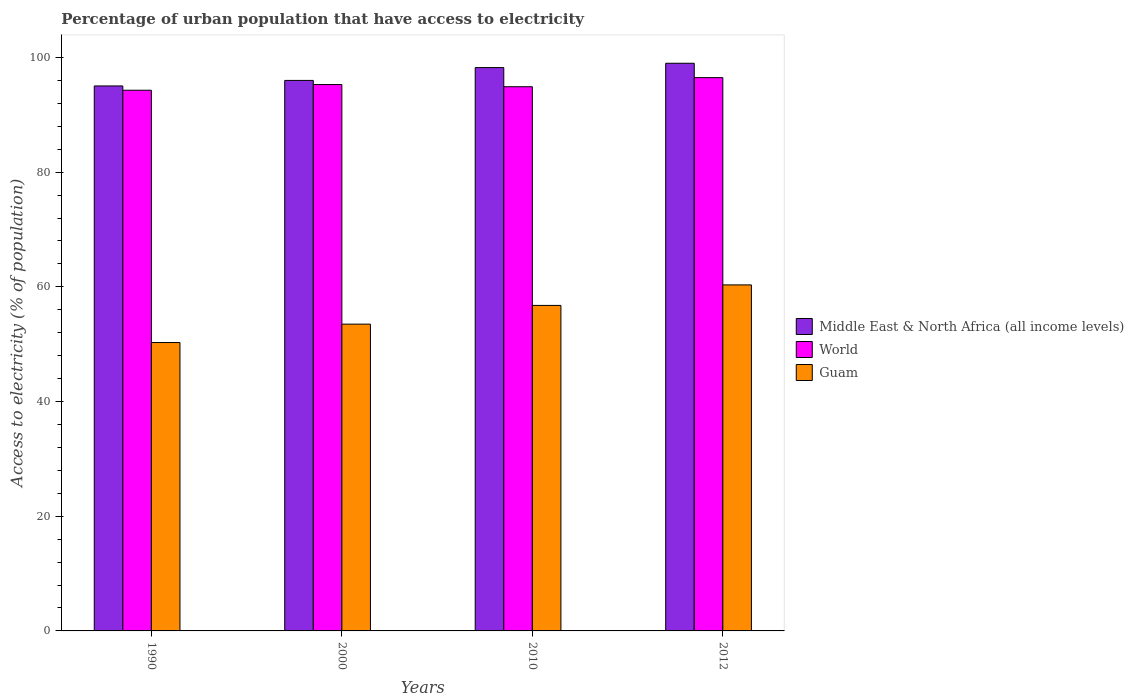How many groups of bars are there?
Your answer should be compact. 4. Are the number of bars per tick equal to the number of legend labels?
Keep it short and to the point. Yes. Are the number of bars on each tick of the X-axis equal?
Ensure brevity in your answer.  Yes. How many bars are there on the 4th tick from the left?
Your response must be concise. 3. What is the percentage of urban population that have access to electricity in World in 2010?
Offer a terse response. 94.89. Across all years, what is the maximum percentage of urban population that have access to electricity in Guam?
Offer a very short reply. 60.33. Across all years, what is the minimum percentage of urban population that have access to electricity in Middle East & North Africa (all income levels)?
Ensure brevity in your answer.  95.03. In which year was the percentage of urban population that have access to electricity in Guam minimum?
Keep it short and to the point. 1990. What is the total percentage of urban population that have access to electricity in Middle East & North Africa (all income levels) in the graph?
Give a very brief answer. 388.23. What is the difference between the percentage of urban population that have access to electricity in Guam in 1990 and that in 2000?
Offer a terse response. -3.21. What is the difference between the percentage of urban population that have access to electricity in Guam in 2010 and the percentage of urban population that have access to electricity in Middle East & North Africa (all income levels) in 1990?
Provide a succinct answer. -38.27. What is the average percentage of urban population that have access to electricity in World per year?
Your response must be concise. 95.23. In the year 2010, what is the difference between the percentage of urban population that have access to electricity in Guam and percentage of urban population that have access to electricity in World?
Keep it short and to the point. -38.13. In how many years, is the percentage of urban population that have access to electricity in Guam greater than 16 %?
Make the answer very short. 4. What is the ratio of the percentage of urban population that have access to electricity in World in 2000 to that in 2012?
Give a very brief answer. 0.99. Is the percentage of urban population that have access to electricity in Middle East & North Africa (all income levels) in 1990 less than that in 2012?
Offer a terse response. Yes. Is the difference between the percentage of urban population that have access to electricity in Guam in 2000 and 2012 greater than the difference between the percentage of urban population that have access to electricity in World in 2000 and 2012?
Make the answer very short. No. What is the difference between the highest and the second highest percentage of urban population that have access to electricity in Guam?
Your response must be concise. 3.58. What is the difference between the highest and the lowest percentage of urban population that have access to electricity in World?
Offer a very short reply. 2.2. What does the 1st bar from the left in 2012 represents?
Your answer should be very brief. Middle East & North Africa (all income levels). What does the 2nd bar from the right in 2000 represents?
Keep it short and to the point. World. How many bars are there?
Provide a succinct answer. 12. Are all the bars in the graph horizontal?
Your answer should be very brief. No. How many years are there in the graph?
Give a very brief answer. 4. Does the graph contain grids?
Provide a succinct answer. No. How many legend labels are there?
Give a very brief answer. 3. What is the title of the graph?
Offer a terse response. Percentage of urban population that have access to electricity. What is the label or title of the Y-axis?
Ensure brevity in your answer.  Access to electricity (% of population). What is the Access to electricity (% of population) of Middle East & North Africa (all income levels) in 1990?
Provide a succinct answer. 95.03. What is the Access to electricity (% of population) of World in 1990?
Your response must be concise. 94.28. What is the Access to electricity (% of population) in Guam in 1990?
Offer a very short reply. 50.28. What is the Access to electricity (% of population) in Middle East & North Africa (all income levels) in 2000?
Provide a succinct answer. 95.99. What is the Access to electricity (% of population) in World in 2000?
Keep it short and to the point. 95.27. What is the Access to electricity (% of population) of Guam in 2000?
Provide a short and direct response. 53.49. What is the Access to electricity (% of population) of Middle East & North Africa (all income levels) in 2010?
Your answer should be very brief. 98.23. What is the Access to electricity (% of population) in World in 2010?
Provide a short and direct response. 94.89. What is the Access to electricity (% of population) of Guam in 2010?
Make the answer very short. 56.76. What is the Access to electricity (% of population) of Middle East & North Africa (all income levels) in 2012?
Your response must be concise. 98.98. What is the Access to electricity (% of population) of World in 2012?
Ensure brevity in your answer.  96.48. What is the Access to electricity (% of population) in Guam in 2012?
Make the answer very short. 60.33. Across all years, what is the maximum Access to electricity (% of population) of Middle East & North Africa (all income levels)?
Offer a terse response. 98.98. Across all years, what is the maximum Access to electricity (% of population) in World?
Provide a short and direct response. 96.48. Across all years, what is the maximum Access to electricity (% of population) of Guam?
Make the answer very short. 60.33. Across all years, what is the minimum Access to electricity (% of population) of Middle East & North Africa (all income levels)?
Provide a short and direct response. 95.03. Across all years, what is the minimum Access to electricity (% of population) in World?
Your answer should be very brief. 94.28. Across all years, what is the minimum Access to electricity (% of population) in Guam?
Your answer should be compact. 50.28. What is the total Access to electricity (% of population) in Middle East & North Africa (all income levels) in the graph?
Offer a very short reply. 388.23. What is the total Access to electricity (% of population) in World in the graph?
Your response must be concise. 380.92. What is the total Access to electricity (% of population) in Guam in the graph?
Ensure brevity in your answer.  220.87. What is the difference between the Access to electricity (% of population) in Middle East & North Africa (all income levels) in 1990 and that in 2000?
Your response must be concise. -0.96. What is the difference between the Access to electricity (% of population) in World in 1990 and that in 2000?
Offer a very short reply. -0.99. What is the difference between the Access to electricity (% of population) in Guam in 1990 and that in 2000?
Your answer should be compact. -3.21. What is the difference between the Access to electricity (% of population) in Middle East & North Africa (all income levels) in 1990 and that in 2010?
Provide a short and direct response. -3.2. What is the difference between the Access to electricity (% of population) of World in 1990 and that in 2010?
Your answer should be very brief. -0.61. What is the difference between the Access to electricity (% of population) in Guam in 1990 and that in 2010?
Offer a terse response. -6.48. What is the difference between the Access to electricity (% of population) of Middle East & North Africa (all income levels) in 1990 and that in 2012?
Your answer should be very brief. -3.96. What is the difference between the Access to electricity (% of population) in World in 1990 and that in 2012?
Give a very brief answer. -2.2. What is the difference between the Access to electricity (% of population) in Guam in 1990 and that in 2012?
Offer a very short reply. -10.05. What is the difference between the Access to electricity (% of population) of Middle East & North Africa (all income levels) in 2000 and that in 2010?
Your response must be concise. -2.24. What is the difference between the Access to electricity (% of population) in World in 2000 and that in 2010?
Give a very brief answer. 0.38. What is the difference between the Access to electricity (% of population) of Guam in 2000 and that in 2010?
Your answer should be compact. -3.27. What is the difference between the Access to electricity (% of population) in Middle East & North Africa (all income levels) in 2000 and that in 2012?
Ensure brevity in your answer.  -2.99. What is the difference between the Access to electricity (% of population) of World in 2000 and that in 2012?
Offer a terse response. -1.21. What is the difference between the Access to electricity (% of population) of Guam in 2000 and that in 2012?
Your answer should be very brief. -6.84. What is the difference between the Access to electricity (% of population) of Middle East & North Africa (all income levels) in 2010 and that in 2012?
Make the answer very short. -0.76. What is the difference between the Access to electricity (% of population) in World in 2010 and that in 2012?
Give a very brief answer. -1.59. What is the difference between the Access to electricity (% of population) of Guam in 2010 and that in 2012?
Keep it short and to the point. -3.58. What is the difference between the Access to electricity (% of population) of Middle East & North Africa (all income levels) in 1990 and the Access to electricity (% of population) of World in 2000?
Provide a short and direct response. -0.24. What is the difference between the Access to electricity (% of population) of Middle East & North Africa (all income levels) in 1990 and the Access to electricity (% of population) of Guam in 2000?
Your response must be concise. 41.53. What is the difference between the Access to electricity (% of population) of World in 1990 and the Access to electricity (% of population) of Guam in 2000?
Give a very brief answer. 40.79. What is the difference between the Access to electricity (% of population) of Middle East & North Africa (all income levels) in 1990 and the Access to electricity (% of population) of World in 2010?
Your answer should be very brief. 0.14. What is the difference between the Access to electricity (% of population) in Middle East & North Africa (all income levels) in 1990 and the Access to electricity (% of population) in Guam in 2010?
Your answer should be compact. 38.27. What is the difference between the Access to electricity (% of population) of World in 1990 and the Access to electricity (% of population) of Guam in 2010?
Offer a terse response. 37.52. What is the difference between the Access to electricity (% of population) in Middle East & North Africa (all income levels) in 1990 and the Access to electricity (% of population) in World in 2012?
Your answer should be very brief. -1.45. What is the difference between the Access to electricity (% of population) of Middle East & North Africa (all income levels) in 1990 and the Access to electricity (% of population) of Guam in 2012?
Ensure brevity in your answer.  34.69. What is the difference between the Access to electricity (% of population) of World in 1990 and the Access to electricity (% of population) of Guam in 2012?
Your answer should be very brief. 33.94. What is the difference between the Access to electricity (% of population) in Middle East & North Africa (all income levels) in 2000 and the Access to electricity (% of population) in World in 2010?
Your response must be concise. 1.1. What is the difference between the Access to electricity (% of population) of Middle East & North Africa (all income levels) in 2000 and the Access to electricity (% of population) of Guam in 2010?
Provide a short and direct response. 39.23. What is the difference between the Access to electricity (% of population) in World in 2000 and the Access to electricity (% of population) in Guam in 2010?
Ensure brevity in your answer.  38.51. What is the difference between the Access to electricity (% of population) in Middle East & North Africa (all income levels) in 2000 and the Access to electricity (% of population) in World in 2012?
Your response must be concise. -0.49. What is the difference between the Access to electricity (% of population) in Middle East & North Africa (all income levels) in 2000 and the Access to electricity (% of population) in Guam in 2012?
Your answer should be compact. 35.66. What is the difference between the Access to electricity (% of population) in World in 2000 and the Access to electricity (% of population) in Guam in 2012?
Provide a short and direct response. 34.93. What is the difference between the Access to electricity (% of population) in Middle East & North Africa (all income levels) in 2010 and the Access to electricity (% of population) in World in 2012?
Offer a terse response. 1.75. What is the difference between the Access to electricity (% of population) of Middle East & North Africa (all income levels) in 2010 and the Access to electricity (% of population) of Guam in 2012?
Keep it short and to the point. 37.89. What is the difference between the Access to electricity (% of population) of World in 2010 and the Access to electricity (% of population) of Guam in 2012?
Give a very brief answer. 34.56. What is the average Access to electricity (% of population) in Middle East & North Africa (all income levels) per year?
Your answer should be compact. 97.06. What is the average Access to electricity (% of population) in World per year?
Your answer should be very brief. 95.23. What is the average Access to electricity (% of population) of Guam per year?
Ensure brevity in your answer.  55.22. In the year 1990, what is the difference between the Access to electricity (% of population) in Middle East & North Africa (all income levels) and Access to electricity (% of population) in World?
Give a very brief answer. 0.75. In the year 1990, what is the difference between the Access to electricity (% of population) of Middle East & North Africa (all income levels) and Access to electricity (% of population) of Guam?
Your response must be concise. 44.74. In the year 1990, what is the difference between the Access to electricity (% of population) in World and Access to electricity (% of population) in Guam?
Offer a very short reply. 44. In the year 2000, what is the difference between the Access to electricity (% of population) of Middle East & North Africa (all income levels) and Access to electricity (% of population) of World?
Your answer should be very brief. 0.72. In the year 2000, what is the difference between the Access to electricity (% of population) of Middle East & North Africa (all income levels) and Access to electricity (% of population) of Guam?
Provide a short and direct response. 42.5. In the year 2000, what is the difference between the Access to electricity (% of population) in World and Access to electricity (% of population) in Guam?
Your answer should be very brief. 41.77. In the year 2010, what is the difference between the Access to electricity (% of population) of Middle East & North Africa (all income levels) and Access to electricity (% of population) of World?
Your answer should be very brief. 3.34. In the year 2010, what is the difference between the Access to electricity (% of population) in Middle East & North Africa (all income levels) and Access to electricity (% of population) in Guam?
Your answer should be compact. 41.47. In the year 2010, what is the difference between the Access to electricity (% of population) of World and Access to electricity (% of population) of Guam?
Your answer should be very brief. 38.13. In the year 2012, what is the difference between the Access to electricity (% of population) in Middle East & North Africa (all income levels) and Access to electricity (% of population) in World?
Offer a terse response. 2.51. In the year 2012, what is the difference between the Access to electricity (% of population) in Middle East & North Africa (all income levels) and Access to electricity (% of population) in Guam?
Your answer should be compact. 38.65. In the year 2012, what is the difference between the Access to electricity (% of population) of World and Access to electricity (% of population) of Guam?
Your response must be concise. 36.14. What is the ratio of the Access to electricity (% of population) in Middle East & North Africa (all income levels) in 1990 to that in 2000?
Offer a terse response. 0.99. What is the ratio of the Access to electricity (% of population) of World in 1990 to that in 2000?
Your response must be concise. 0.99. What is the ratio of the Access to electricity (% of population) of Guam in 1990 to that in 2000?
Offer a very short reply. 0.94. What is the ratio of the Access to electricity (% of population) in Middle East & North Africa (all income levels) in 1990 to that in 2010?
Offer a terse response. 0.97. What is the ratio of the Access to electricity (% of population) of Guam in 1990 to that in 2010?
Offer a terse response. 0.89. What is the ratio of the Access to electricity (% of population) of Middle East & North Africa (all income levels) in 1990 to that in 2012?
Ensure brevity in your answer.  0.96. What is the ratio of the Access to electricity (% of population) in World in 1990 to that in 2012?
Provide a succinct answer. 0.98. What is the ratio of the Access to electricity (% of population) of Guam in 1990 to that in 2012?
Your response must be concise. 0.83. What is the ratio of the Access to electricity (% of population) of Middle East & North Africa (all income levels) in 2000 to that in 2010?
Provide a succinct answer. 0.98. What is the ratio of the Access to electricity (% of population) of Guam in 2000 to that in 2010?
Provide a short and direct response. 0.94. What is the ratio of the Access to electricity (% of population) in Middle East & North Africa (all income levels) in 2000 to that in 2012?
Your response must be concise. 0.97. What is the ratio of the Access to electricity (% of population) of World in 2000 to that in 2012?
Provide a short and direct response. 0.99. What is the ratio of the Access to electricity (% of population) of Guam in 2000 to that in 2012?
Provide a succinct answer. 0.89. What is the ratio of the Access to electricity (% of population) in World in 2010 to that in 2012?
Your response must be concise. 0.98. What is the ratio of the Access to electricity (% of population) of Guam in 2010 to that in 2012?
Give a very brief answer. 0.94. What is the difference between the highest and the second highest Access to electricity (% of population) of Middle East & North Africa (all income levels)?
Ensure brevity in your answer.  0.76. What is the difference between the highest and the second highest Access to electricity (% of population) in World?
Ensure brevity in your answer.  1.21. What is the difference between the highest and the second highest Access to electricity (% of population) in Guam?
Offer a very short reply. 3.58. What is the difference between the highest and the lowest Access to electricity (% of population) in Middle East & North Africa (all income levels)?
Your response must be concise. 3.96. What is the difference between the highest and the lowest Access to electricity (% of population) in World?
Keep it short and to the point. 2.2. What is the difference between the highest and the lowest Access to electricity (% of population) of Guam?
Ensure brevity in your answer.  10.05. 